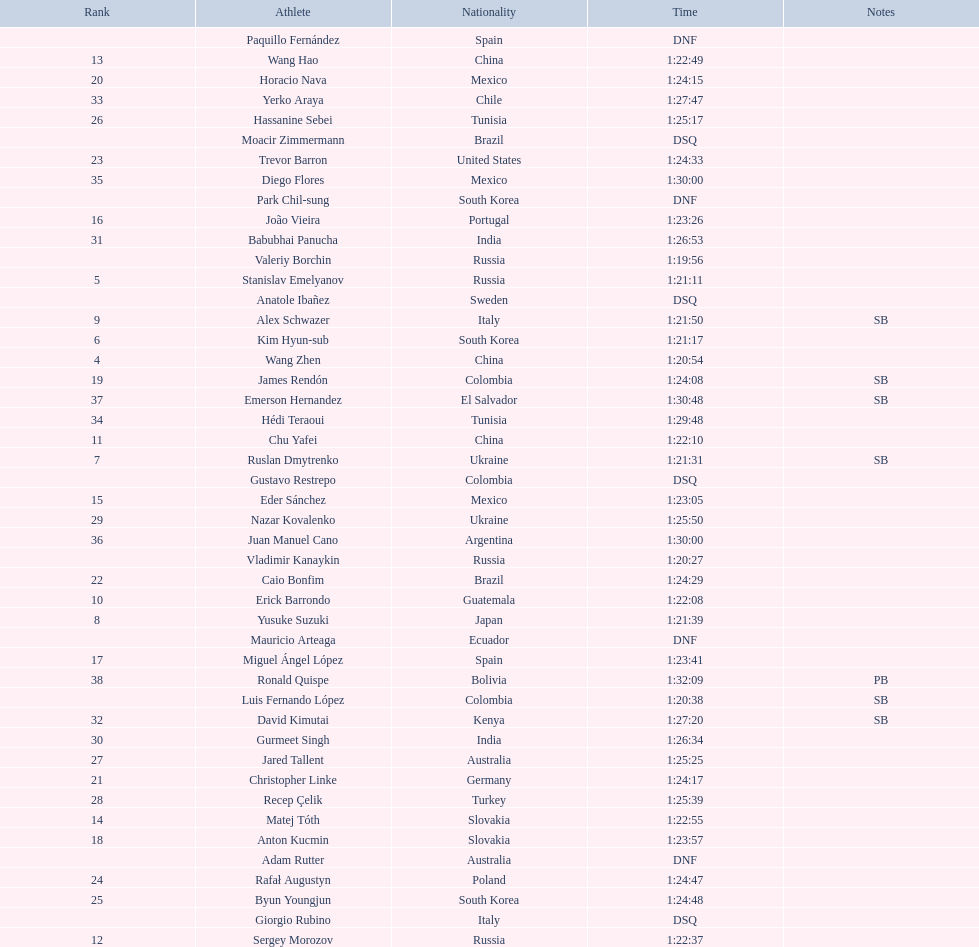Which athlete had the fastest time for the 20km? Valeriy Borchin. Write the full table. {'header': ['Rank', 'Athlete', 'Nationality', 'Time', 'Notes'], 'rows': [['', 'Paquillo Fernández', 'Spain', 'DNF', ''], ['13', 'Wang Hao', 'China', '1:22:49', ''], ['20', 'Horacio Nava', 'Mexico', '1:24:15', ''], ['33', 'Yerko Araya', 'Chile', '1:27:47', ''], ['26', 'Hassanine Sebei', 'Tunisia', '1:25:17', ''], ['', 'Moacir Zimmermann', 'Brazil', 'DSQ', ''], ['23', 'Trevor Barron', 'United States', '1:24:33', ''], ['35', 'Diego Flores', 'Mexico', '1:30:00', ''], ['', 'Park Chil-sung', 'South Korea', 'DNF', ''], ['16', 'João Vieira', 'Portugal', '1:23:26', ''], ['31', 'Babubhai Panucha', 'India', '1:26:53', ''], ['', 'Valeriy Borchin', 'Russia', '1:19:56', ''], ['5', 'Stanislav Emelyanov', 'Russia', '1:21:11', ''], ['', 'Anatole Ibañez', 'Sweden', 'DSQ', ''], ['9', 'Alex Schwazer', 'Italy', '1:21:50', 'SB'], ['6', 'Kim Hyun-sub', 'South Korea', '1:21:17', ''], ['4', 'Wang Zhen', 'China', '1:20:54', ''], ['19', 'James Rendón', 'Colombia', '1:24:08', 'SB'], ['37', 'Emerson Hernandez', 'El Salvador', '1:30:48', 'SB'], ['34', 'Hédi Teraoui', 'Tunisia', '1:29:48', ''], ['11', 'Chu Yafei', 'China', '1:22:10', ''], ['7', 'Ruslan Dmytrenko', 'Ukraine', '1:21:31', 'SB'], ['', 'Gustavo Restrepo', 'Colombia', 'DSQ', ''], ['15', 'Eder Sánchez', 'Mexico', '1:23:05', ''], ['29', 'Nazar Kovalenko', 'Ukraine', '1:25:50', ''], ['36', 'Juan Manuel Cano', 'Argentina', '1:30:00', ''], ['', 'Vladimir Kanaykin', 'Russia', '1:20:27', ''], ['22', 'Caio Bonfim', 'Brazil', '1:24:29', ''], ['10', 'Erick Barrondo', 'Guatemala', '1:22:08', ''], ['8', 'Yusuke Suzuki', 'Japan', '1:21:39', ''], ['', 'Mauricio Arteaga', 'Ecuador', 'DNF', ''], ['17', 'Miguel Ángel López', 'Spain', '1:23:41', ''], ['38', 'Ronald Quispe', 'Bolivia', '1:32:09', 'PB'], ['', 'Luis Fernando López', 'Colombia', '1:20:38', 'SB'], ['32', 'David Kimutai', 'Kenya', '1:27:20', 'SB'], ['30', 'Gurmeet Singh', 'India', '1:26:34', ''], ['27', 'Jared Tallent', 'Australia', '1:25:25', ''], ['21', 'Christopher Linke', 'Germany', '1:24:17', ''], ['28', 'Recep Çelik', 'Turkey', '1:25:39', ''], ['14', 'Matej Tóth', 'Slovakia', '1:22:55', ''], ['18', 'Anton Kucmin', 'Slovakia', '1:23:57', ''], ['', 'Adam Rutter', 'Australia', 'DNF', ''], ['24', 'Rafał Augustyn', 'Poland', '1:24:47', ''], ['25', 'Byun Youngjun', 'South Korea', '1:24:48', ''], ['', 'Giorgio Rubino', 'Italy', 'DSQ', ''], ['12', 'Sergey Morozov', 'Russia', '1:22:37', '']]} 